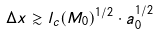Convert formula to latex. <formula><loc_0><loc_0><loc_500><loc_500>\Delta x \gtrsim l _ { c } ( M _ { 0 } ) ^ { 1 / 2 } \cdot a _ { 0 } ^ { 1 / 2 }</formula> 